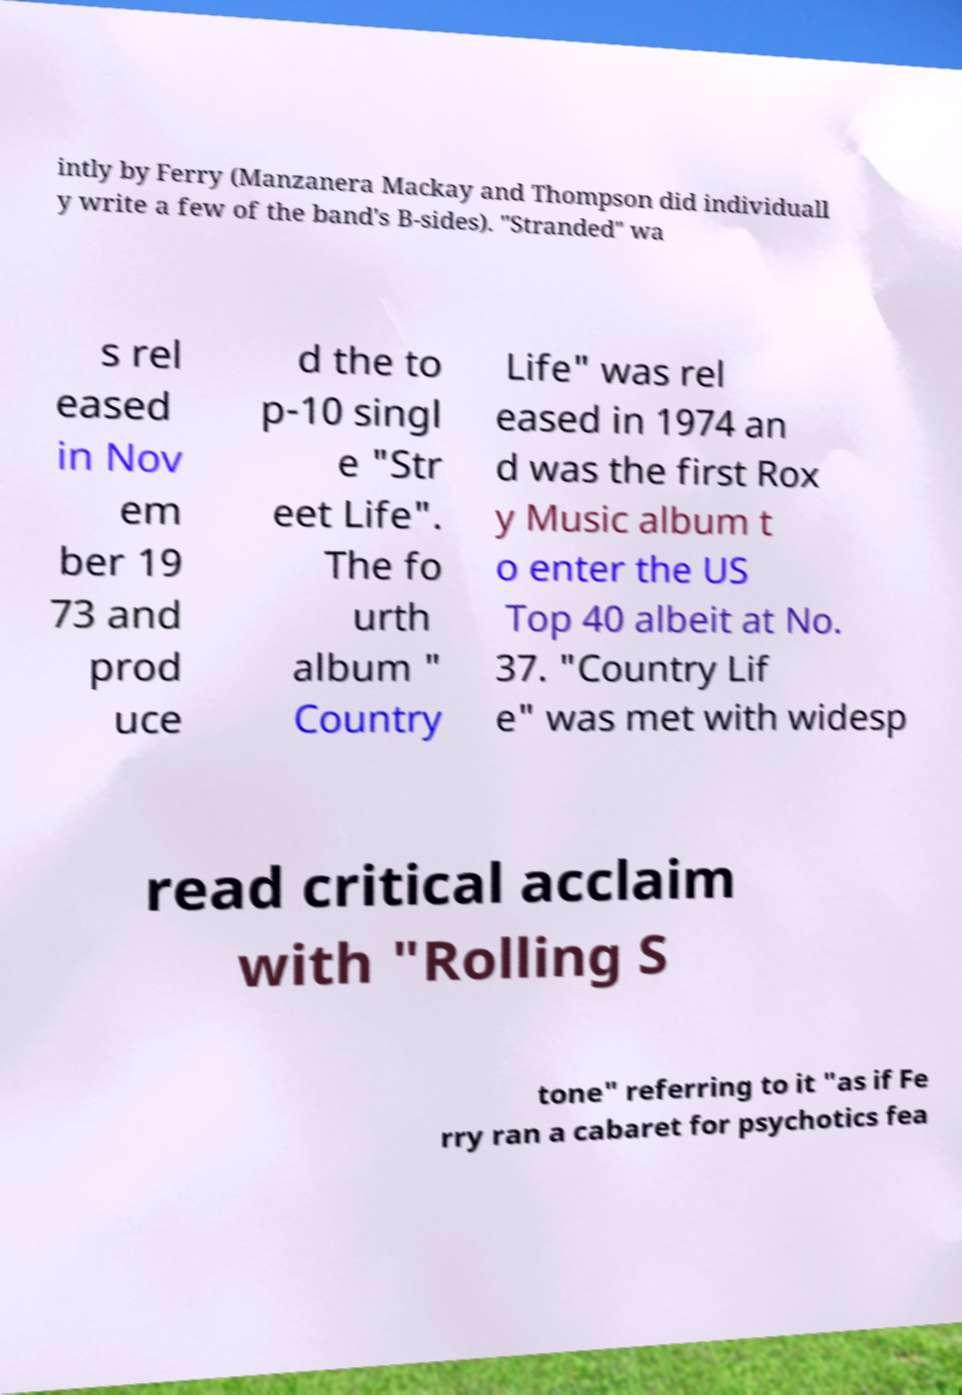Please read and relay the text visible in this image. What does it say? intly by Ferry (Manzanera Mackay and Thompson did individuall y write a few of the band's B-sides). "Stranded" wa s rel eased in Nov em ber 19 73 and prod uce d the to p-10 singl e "Str eet Life". The fo urth album " Country Life" was rel eased in 1974 an d was the first Rox y Music album t o enter the US Top 40 albeit at No. 37. "Country Lif e" was met with widesp read critical acclaim with "Rolling S tone" referring to it "as if Fe rry ran a cabaret for psychotics fea 